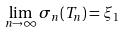<formula> <loc_0><loc_0><loc_500><loc_500>\lim _ { n \rightarrow \infty } \sigma _ { n } ( T _ { n } ) = \xi _ { 1 }</formula> 